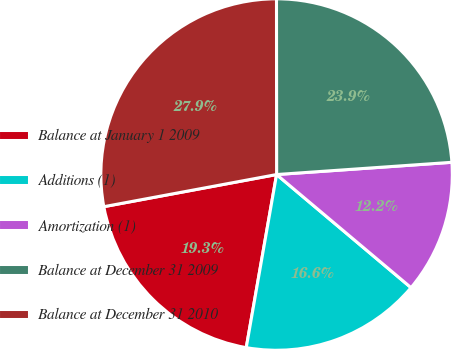Convert chart to OTSL. <chart><loc_0><loc_0><loc_500><loc_500><pie_chart><fcel>Balance at January 1 2009<fcel>Additions (1)<fcel>Amortization (1)<fcel>Balance at December 31 2009<fcel>Balance at December 31 2010<nl><fcel>19.31%<fcel>16.63%<fcel>12.24%<fcel>23.9%<fcel>27.92%<nl></chart> 